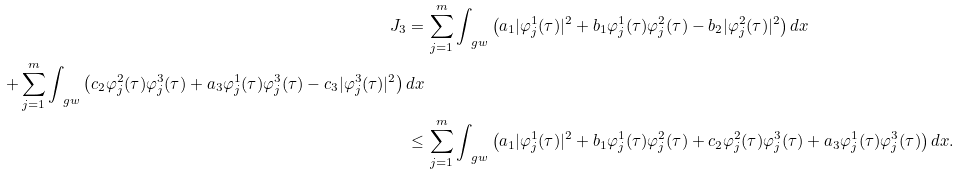Convert formula to latex. <formula><loc_0><loc_0><loc_500><loc_500>J _ { 3 } = & \, \sum _ { j = 1 } ^ { m } \int _ { \ g w } \left ( a _ { 1 } | \varphi _ { j } ^ { 1 } ( \tau ) | ^ { 2 } + b _ { 1 } \varphi _ { j } ^ { 1 } ( \tau ) \varphi _ { j } ^ { 2 } ( \tau ) - b _ { 2 } | \varphi _ { j } ^ { 2 } ( \tau ) | ^ { 2 } \right ) d x \\ + \sum _ { j = 1 } ^ { m } \int _ { \ g w } \left ( c _ { 2 } \varphi _ { j } ^ { 2 } ( \tau ) \varphi _ { j } ^ { 3 } ( \tau ) + a _ { 3 } \varphi _ { j } ^ { 1 } ( \tau ) \varphi _ { j } ^ { 3 } ( \tau ) - c _ { 3 } | \varphi _ { j } ^ { 3 } ( \tau ) | ^ { 2 } \right ) d x \\ \leq & \, \sum _ { j = 1 } ^ { m } \int _ { \ g w } \left ( a _ { 1 } | \varphi _ { j } ^ { 1 } ( \tau ) | ^ { 2 } + b _ { 1 } \varphi _ { j } ^ { 1 } ( \tau ) \varphi _ { j } ^ { 2 } ( \tau ) + c _ { 2 } \varphi _ { j } ^ { 2 } ( \tau ) \varphi _ { j } ^ { 3 } ( \tau ) + a _ { 3 } \varphi _ { j } ^ { 1 } ( \tau ) \varphi _ { j } ^ { 3 } ( \tau ) \right ) d x .</formula> 